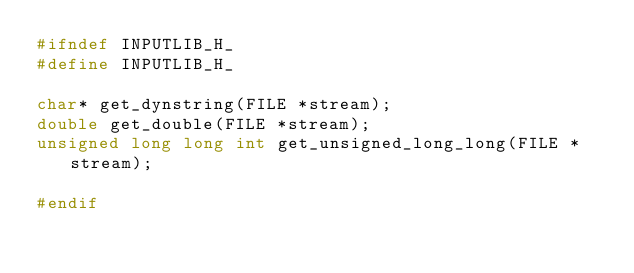Convert code to text. <code><loc_0><loc_0><loc_500><loc_500><_C_>#ifndef INPUTLIB_H_
#define INPUTLIB_H_

char* get_dynstring(FILE *stream);
double get_double(FILE *stream);
unsigned long long int get_unsigned_long_long(FILE *stream);

#endif
</code> 